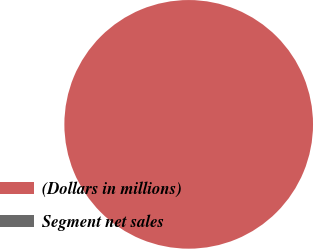Convert chart. <chart><loc_0><loc_0><loc_500><loc_500><pie_chart><fcel>(Dollars in millions)<fcel>Segment net sales<nl><fcel>100.0%<fcel>0.0%<nl></chart> 